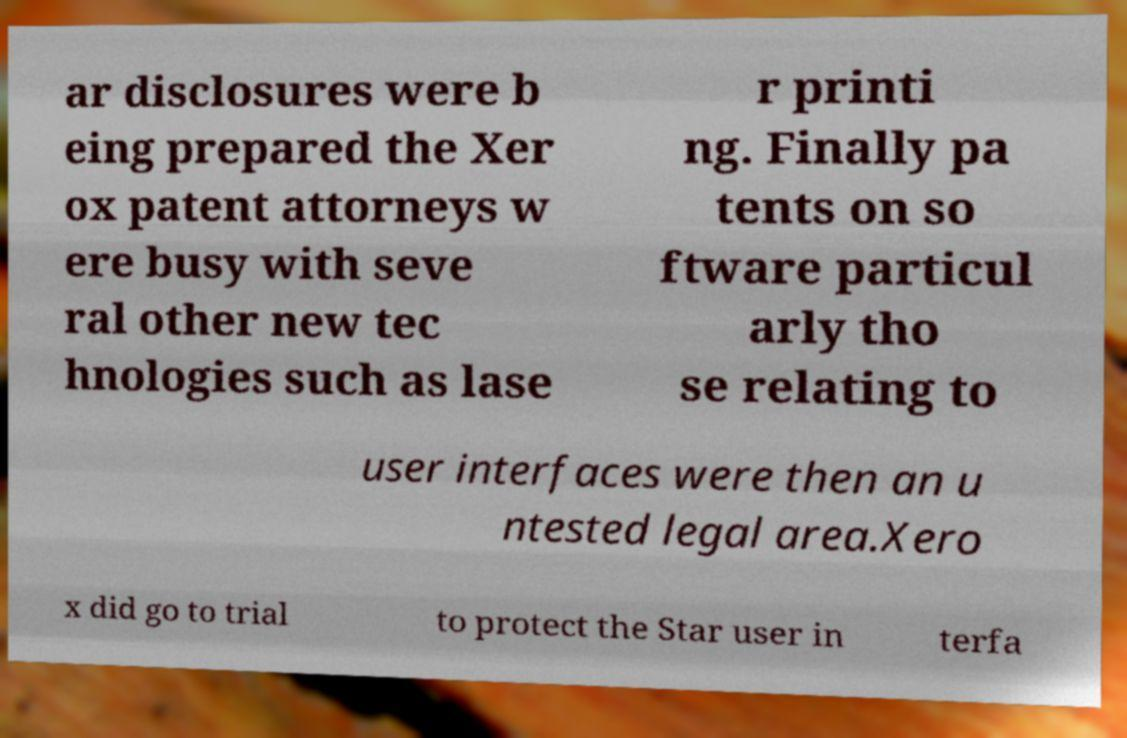Can you accurately transcribe the text from the provided image for me? ar disclosures were b eing prepared the Xer ox patent attorneys w ere busy with seve ral other new tec hnologies such as lase r printi ng. Finally pa tents on so ftware particul arly tho se relating to user interfaces were then an u ntested legal area.Xero x did go to trial to protect the Star user in terfa 